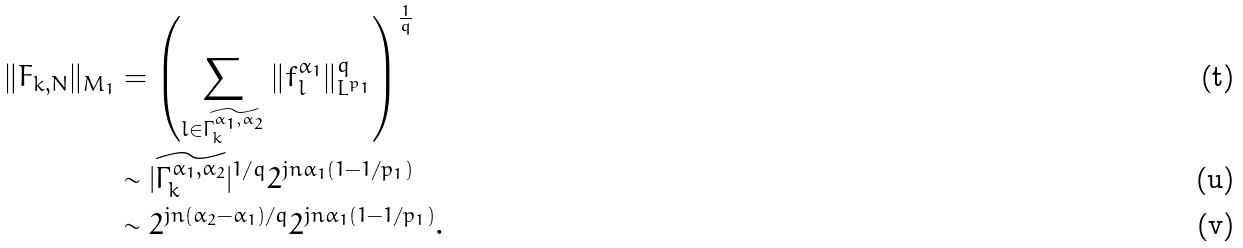<formula> <loc_0><loc_0><loc_500><loc_500>\| F _ { k , N } \| _ { M _ { 1 } } & = \left ( \sum _ { l \in \widetilde { \Gamma _ { k } ^ { \alpha _ { 1 } , \alpha _ { 2 } } } } \| f _ { l } ^ { \alpha _ { 1 } } \| ^ { q } _ { L ^ { p _ { 1 } } } \right ) ^ { \frac { 1 } { q } } \\ & \sim | \widetilde { \Gamma _ { k } ^ { \alpha _ { 1 } , \alpha _ { 2 } } } | ^ { 1 / q } 2 ^ { j n \alpha _ { 1 } ( 1 - 1 / p _ { 1 } ) } \\ & \sim 2 ^ { j n ( \alpha _ { 2 } - \alpha _ { 1 } ) / q } 2 ^ { j n \alpha _ { 1 } ( 1 - 1 / p _ { 1 } ) } .</formula> 